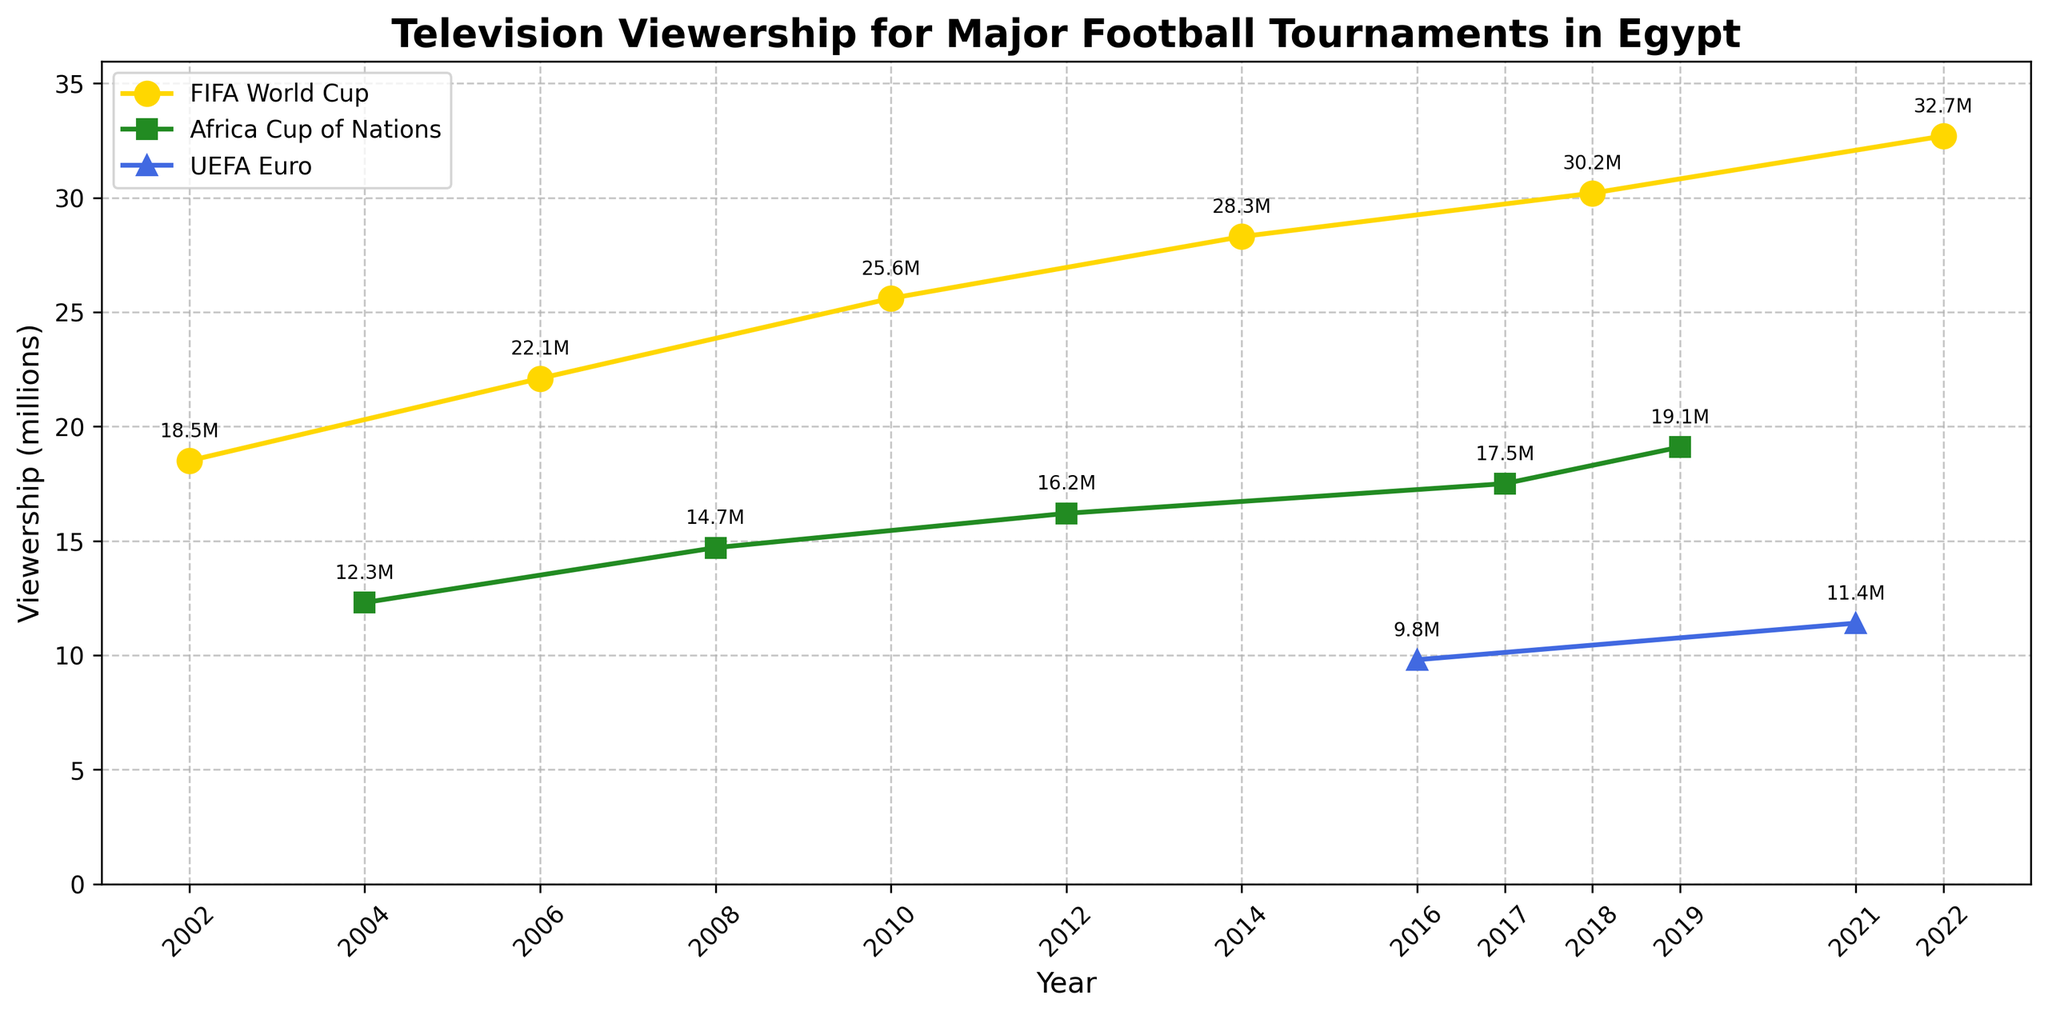What was the Television viewership for the FIFA World Cup in 2018? To find the viewership for the FIFA World Cup in 2018, locate the data point on the line chart corresponding to the year 2018 and the FIFA World Cup series (which should be marked with a specific symbol and/or color).
Answer: 30.2 million Which tournament had the highest viewership in Egypt since 2000? Scan the line chart to identify the highest data point among all the series plotted. Note the corresponding tournament and year.
Answer: FIFA World Cup 2022 How much did the viewership for the Africa Cup of Nations increase from 2004 to 2019? Find the data points for the Africa Cup of Nations in 2004 (12.3 million) and 2019 (19.1 million). Subtract the former from the latter to get the increase.
Answer: 6.8 million What is the average viewership for all FIFA World Cup tournaments shown in the chart? Locate the data points for all the FIFA World Cup years (2002, 2006, 2010, 2014, 2018, 2022). Add these values (18.5 + 22.1 + 25.6 + 28.3 + 30.2 + 32.7) and divide by the number of data points (6).
Answer: 26.23 million Which had a higher viewership in 2016, the UEFA Euro or the Africa Cup of Nations the following year? Identify the viewership values for UEFA Euro in 2016 (9.8 million) and Africa Cup of Nations in 2017 (17.5 million) from the chart. Compare the two values to determine which is higher.
Answer: Africa Cup of Nations 2017 How much did viewership for the UEFA Euro change between 2016 and 2021? Identify the viewership values for the UEFA Euro in 2016 (9.8 million) and 2021 (11.4 million). Subtract the 2016 value from the 2021 value to determine the change.
Answer: 1.6 million In which year did the Africa Cup of Nations reach its peak viewership, and what was the value? Look for the highest data point in the Africa Cup of Nations series on the line chart and note the corresponding year and viewership value.
Answer: 2019, 19.1 million Compare the trend in viewership for the FIFA World Cup and the UEFA Euro over the years. Trace the lines representing FIFA World Cup and UEFA Euro across the years on the chart. Notice the general direction of each line (e.g., increasing, decreasing, or fluctuating).
Answer: FIFA World Cup viewership generally increases, while UEFA Euro viewership shows slight fluctuations Which tournament had a lower viewership in 2012, the Africa Cup of Nations or the FIFA World Cup in the years it was held since 2000? Identify the viewership value for the Africa Cup of Nations in 2012 (16.2 million) and compare it to the viewership values of all FIFA World Cup years (2002, 2006, 2010, 2014, 2018, 2022). Determine if it is less than any of those values.
Answer: All FIFA World Cup years had higher viewership 